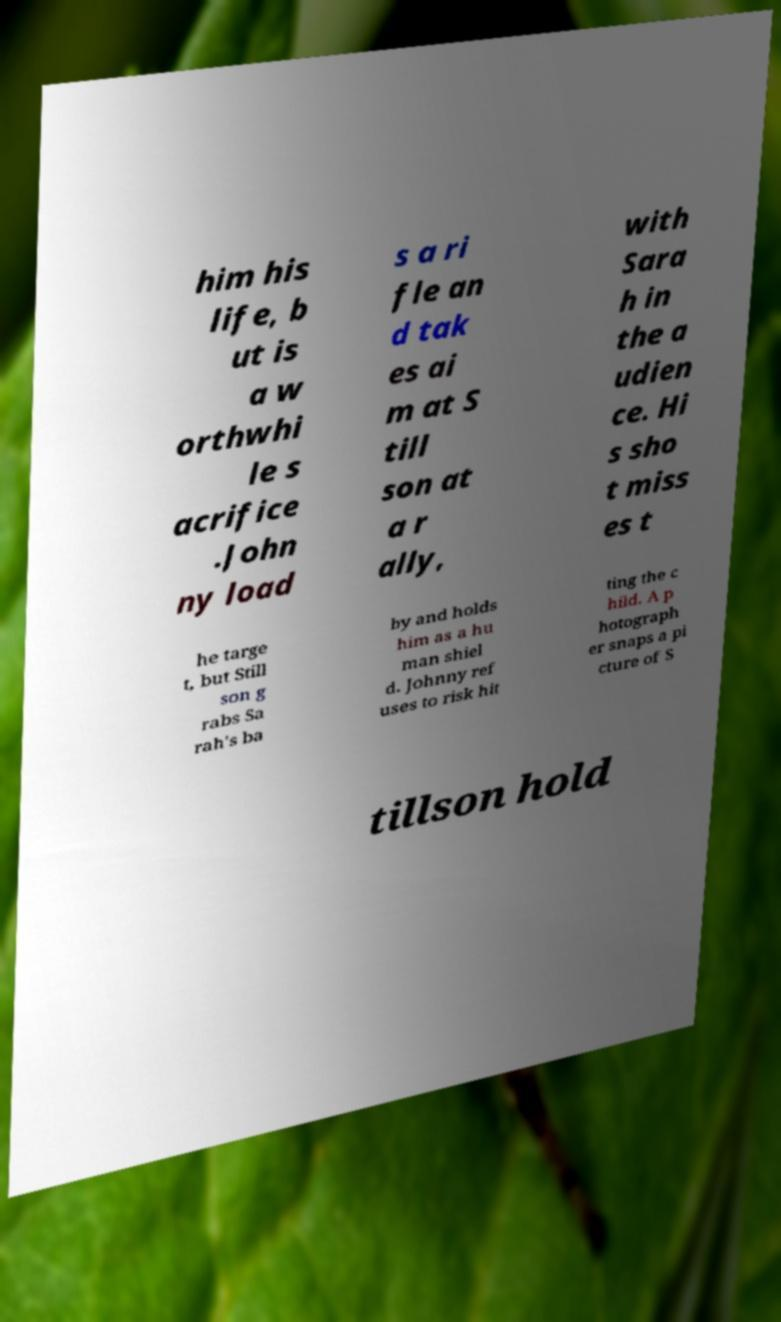There's text embedded in this image that I need extracted. Can you transcribe it verbatim? him his life, b ut is a w orthwhi le s acrifice .John ny load s a ri fle an d tak es ai m at S till son at a r ally, with Sara h in the a udien ce. Hi s sho t miss es t he targe t, but Still son g rabs Sa rah's ba by and holds him as a hu man shiel d. Johnny ref uses to risk hit ting the c hild. A p hotograph er snaps a pi cture of S tillson hold 